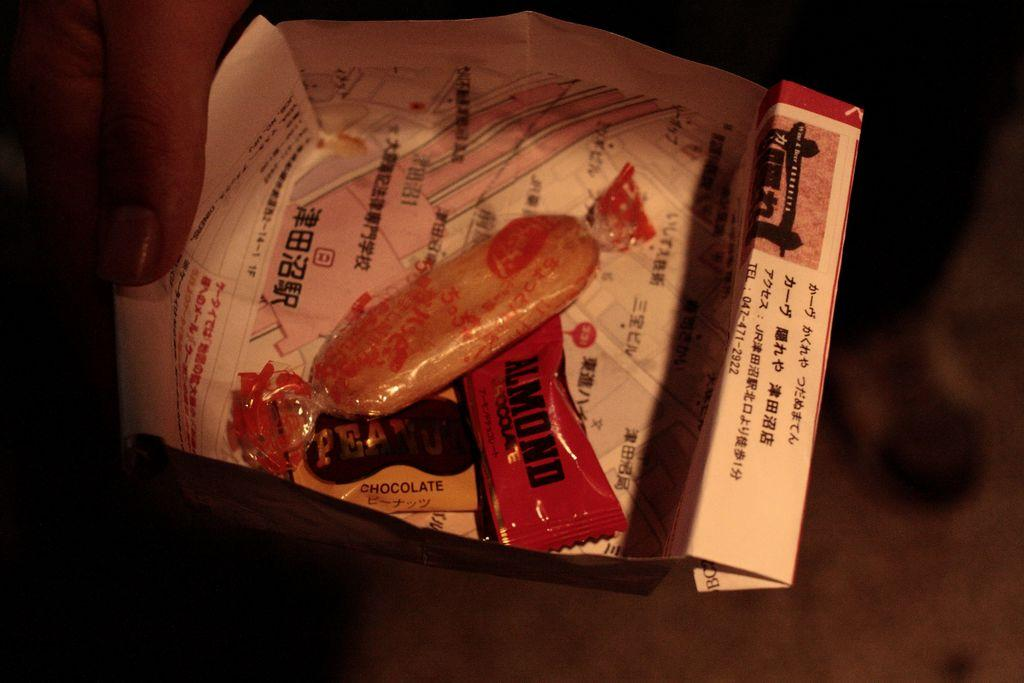What is the overall tone or lighting of the image? The image is dark. Can you describe the person in the image? There is a person in the image. What is the person holding in the image? The person is holding a box. What is inside the box that the person is holding? The box contains candies. How many apples are visible in the image? There are no apples visible in the image. Can you describe the oatmeal that the person is eating in the image? There is no oatmeal present in the image. 